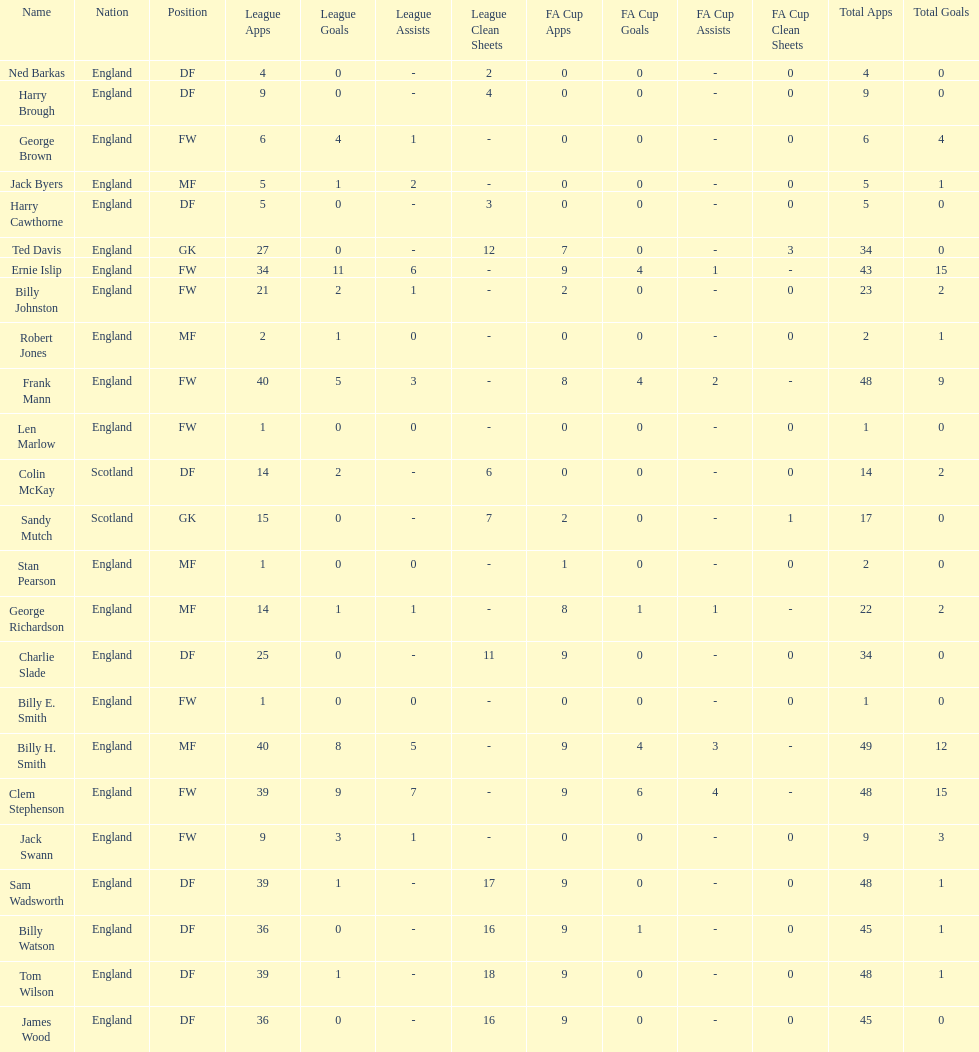The least number of total appearances 1. 